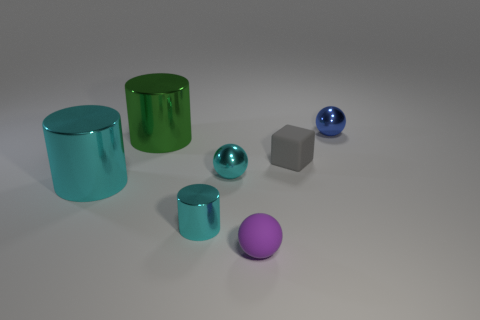Add 1 gray matte objects. How many objects exist? 8 Subtract all cubes. How many objects are left? 6 Subtract all green things. Subtract all cylinders. How many objects are left? 3 Add 4 purple rubber things. How many purple rubber things are left? 5 Add 1 big cyan metallic cylinders. How many big cyan metallic cylinders exist? 2 Subtract 0 brown spheres. How many objects are left? 7 